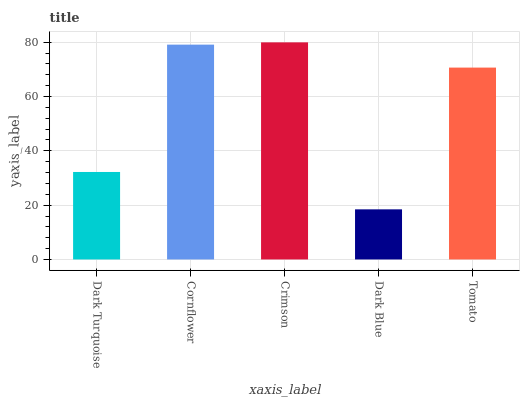Is Dark Blue the minimum?
Answer yes or no. Yes. Is Crimson the maximum?
Answer yes or no. Yes. Is Cornflower the minimum?
Answer yes or no. No. Is Cornflower the maximum?
Answer yes or no. No. Is Cornflower greater than Dark Turquoise?
Answer yes or no. Yes. Is Dark Turquoise less than Cornflower?
Answer yes or no. Yes. Is Dark Turquoise greater than Cornflower?
Answer yes or no. No. Is Cornflower less than Dark Turquoise?
Answer yes or no. No. Is Tomato the high median?
Answer yes or no. Yes. Is Tomato the low median?
Answer yes or no. Yes. Is Crimson the high median?
Answer yes or no. No. Is Crimson the low median?
Answer yes or no. No. 